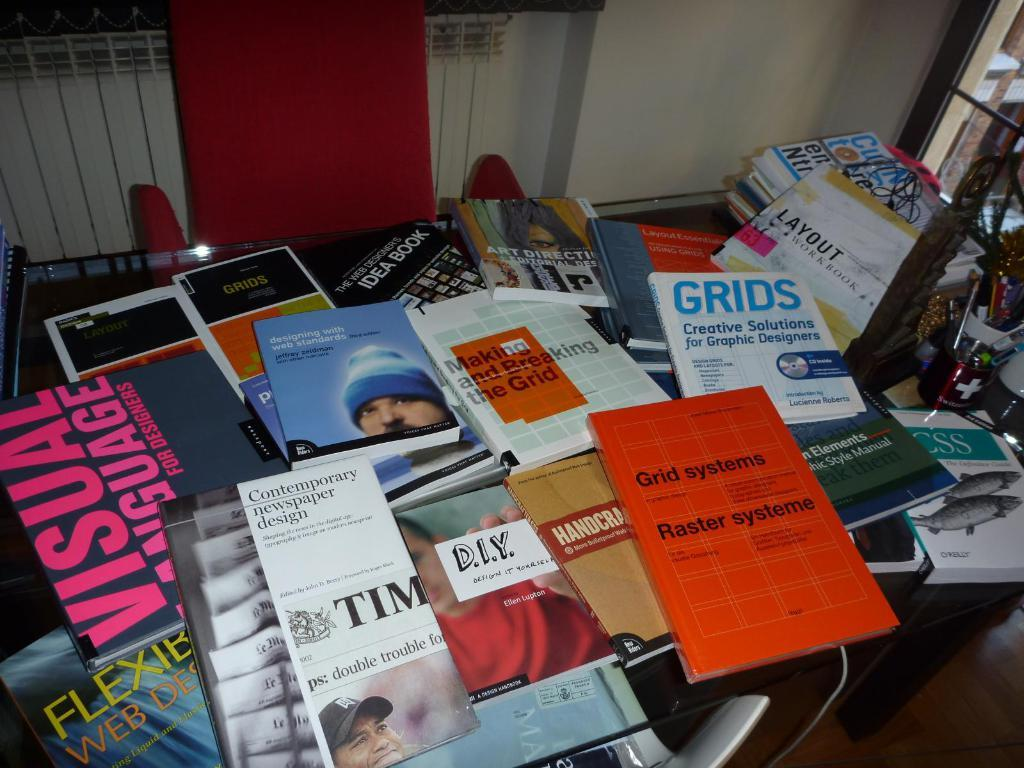<image>
Offer a succinct explanation of the picture presented. Many booklets on a table including one that says Grid Systems. 